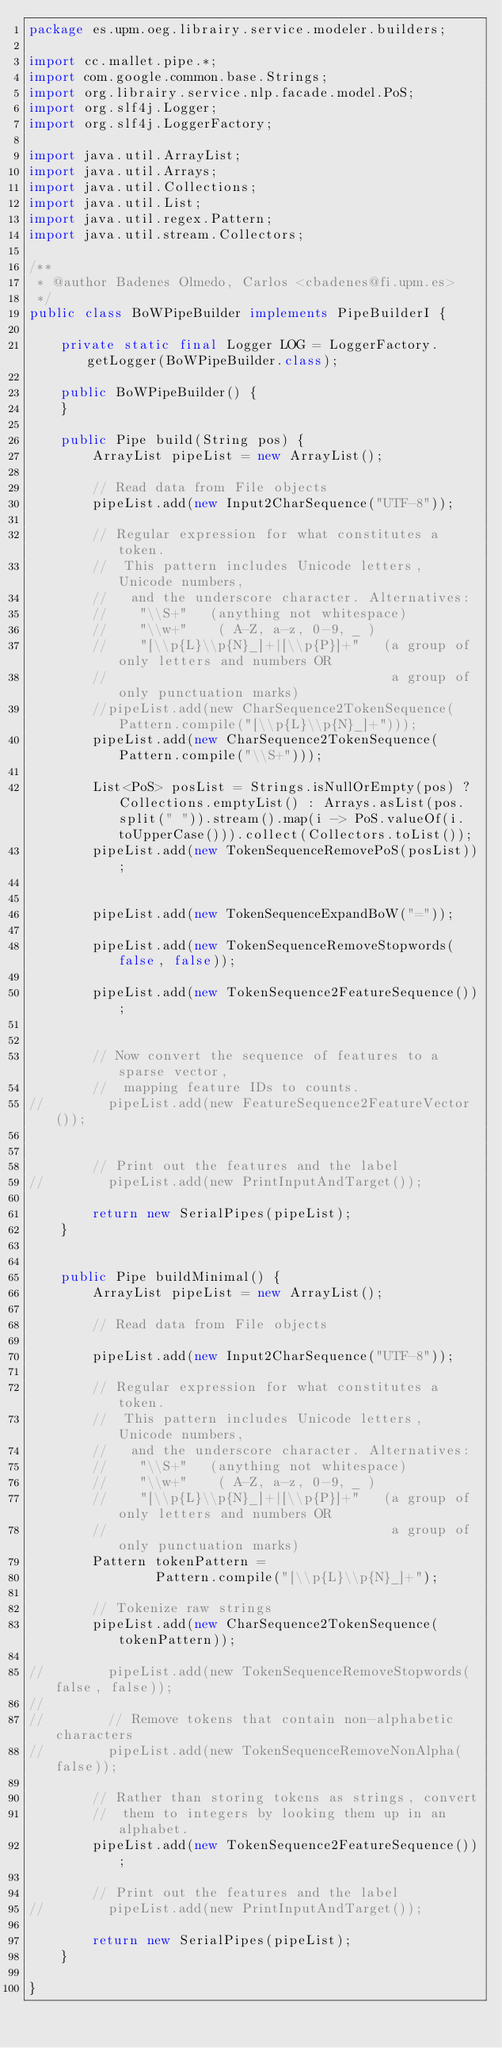Convert code to text. <code><loc_0><loc_0><loc_500><loc_500><_Java_>package es.upm.oeg.librairy.service.modeler.builders;

import cc.mallet.pipe.*;
import com.google.common.base.Strings;
import org.librairy.service.nlp.facade.model.PoS;
import org.slf4j.Logger;
import org.slf4j.LoggerFactory;

import java.util.ArrayList;
import java.util.Arrays;
import java.util.Collections;
import java.util.List;
import java.util.regex.Pattern;
import java.util.stream.Collectors;

/**
 * @author Badenes Olmedo, Carlos <cbadenes@fi.upm.es>
 */
public class BoWPipeBuilder implements PipeBuilderI {

    private static final Logger LOG = LoggerFactory.getLogger(BoWPipeBuilder.class);

    public BoWPipeBuilder() {
    }

    public Pipe build(String pos) {
        ArrayList pipeList = new ArrayList();

        // Read data from File objects
        pipeList.add(new Input2CharSequence("UTF-8"));

        // Regular expression for what constitutes a token.
        //  This pattern includes Unicode letters, Unicode numbers,
        //   and the underscore character. Alternatives:
        //    "\\S+"   (anything not whitespace)
        //    "\\w+"    ( A-Z, a-z, 0-9, _ )
        //    "[\\p{L}\\p{N}_]+|[\\p{P}]+"   (a group of only letters and numbers OR
        //                                    a group of only punctuation marks)
        //pipeList.add(new CharSequence2TokenSequence(Pattern.compile("[\\p{L}\\p{N}_]+")));
        pipeList.add(new CharSequence2TokenSequence(Pattern.compile("\\S+")));

        List<PoS> posList = Strings.isNullOrEmpty(pos) ? Collections.emptyList() : Arrays.asList(pos.split(" ")).stream().map(i -> PoS.valueOf(i.toUpperCase())).collect(Collectors.toList());
        pipeList.add(new TokenSequenceRemovePoS(posList));


        pipeList.add(new TokenSequenceExpandBoW("="));

        pipeList.add(new TokenSequenceRemoveStopwords(false, false));

        pipeList.add(new TokenSequence2FeatureSequence());


        // Now convert the sequence of features to a sparse vector,
        //  mapping feature IDs to counts.
//        pipeList.add(new FeatureSequence2FeatureVector());


        // Print out the features and the label
//        pipeList.add(new PrintInputAndTarget());

        return new SerialPipes(pipeList);
    }


    public Pipe buildMinimal() {
        ArrayList pipeList = new ArrayList();

        // Read data from File objects

        pipeList.add(new Input2CharSequence("UTF-8"));

        // Regular expression for what constitutes a token.
        //  This pattern includes Unicode letters, Unicode numbers,
        //   and the underscore character. Alternatives:
        //    "\\S+"   (anything not whitespace)
        //    "\\w+"    ( A-Z, a-z, 0-9, _ )
        //    "[\\p{L}\\p{N}_]+|[\\p{P}]+"   (a group of only letters and numbers OR
        //                                    a group of only punctuation marks)
        Pattern tokenPattern =
                Pattern.compile("[\\p{L}\\p{N}_]+");

        // Tokenize raw strings
        pipeList.add(new CharSequence2TokenSequence(tokenPattern));

//        pipeList.add(new TokenSequenceRemoveStopwords(false, false));
//
//        // Remove tokens that contain non-alphabetic characters
//        pipeList.add(new TokenSequenceRemoveNonAlpha(false));

        // Rather than storing tokens as strings, convert
        //  them to integers by looking them up in an alphabet.
        pipeList.add(new TokenSequence2FeatureSequence());

        // Print out the features and the label
//        pipeList.add(new PrintInputAndTarget());

        return new SerialPipes(pipeList);
    }

}
</code> 